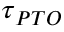<formula> <loc_0><loc_0><loc_500><loc_500>\tau _ { P T O }</formula> 